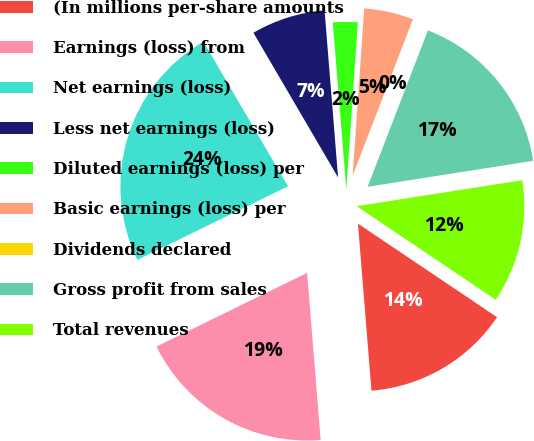Convert chart. <chart><loc_0><loc_0><loc_500><loc_500><pie_chart><fcel>(In millions per-share amounts<fcel>Earnings (loss) from<fcel>Net earnings (loss)<fcel>Less net earnings (loss)<fcel>Diluted earnings (loss) per<fcel>Basic earnings (loss) per<fcel>Dividends declared<fcel>Gross profit from sales<fcel>Total revenues<nl><fcel>14.29%<fcel>19.05%<fcel>23.81%<fcel>7.14%<fcel>2.38%<fcel>4.76%<fcel>0.0%<fcel>16.67%<fcel>11.9%<nl></chart> 